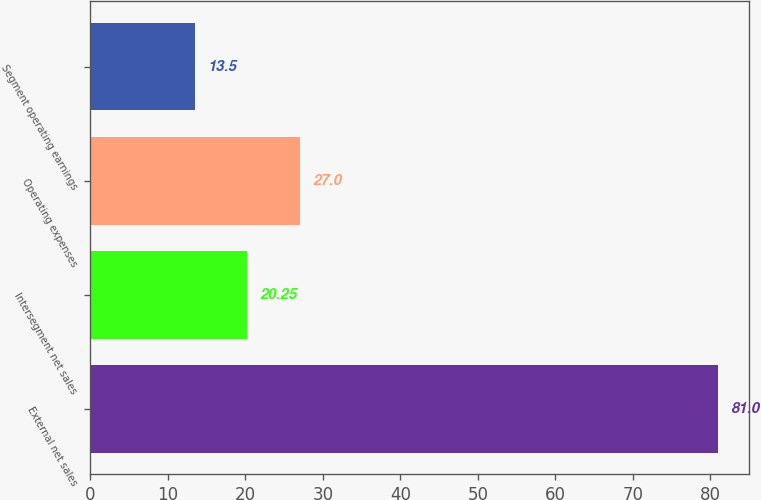<chart> <loc_0><loc_0><loc_500><loc_500><bar_chart><fcel>External net sales<fcel>Intersegment net sales<fcel>Operating expenses<fcel>Segment operating earnings<nl><fcel>81<fcel>20.25<fcel>27<fcel>13.5<nl></chart> 